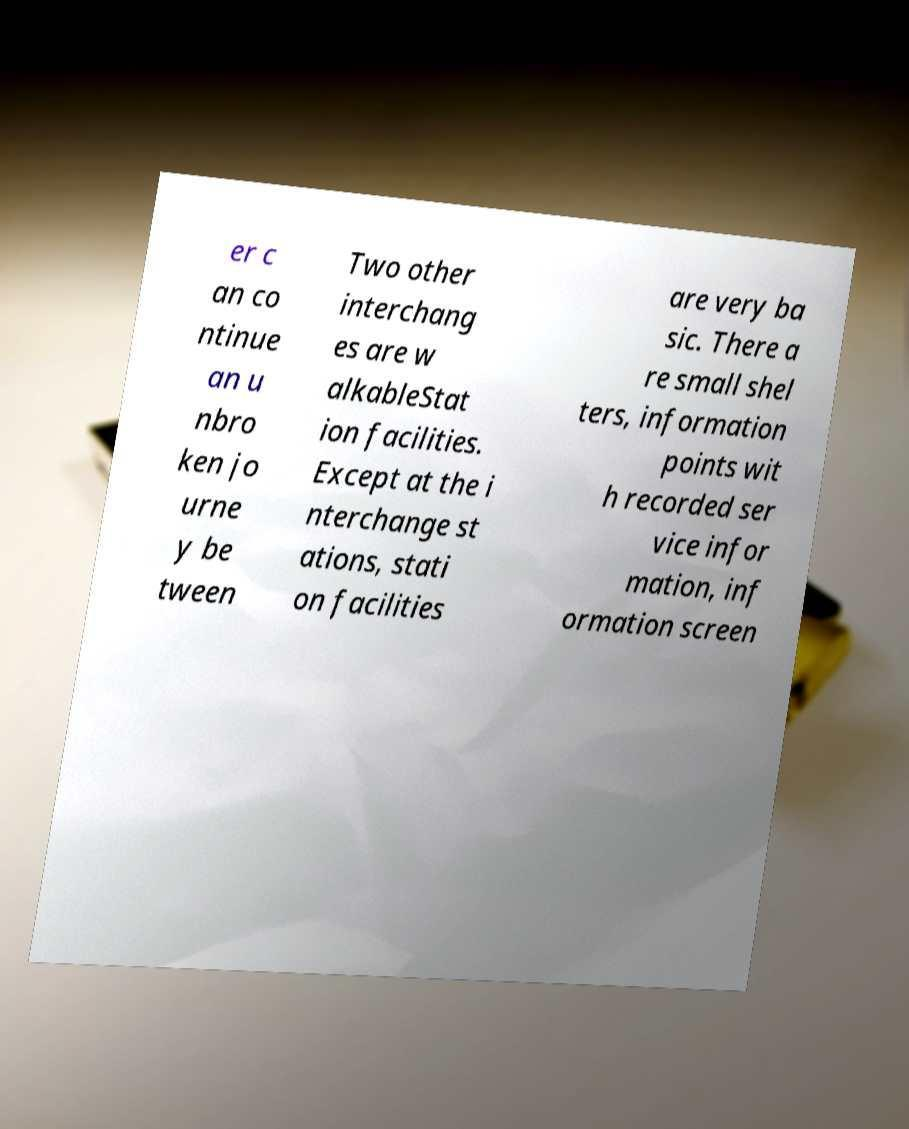Please identify and transcribe the text found in this image. er c an co ntinue an u nbro ken jo urne y be tween Two other interchang es are w alkableStat ion facilities. Except at the i nterchange st ations, stati on facilities are very ba sic. There a re small shel ters, information points wit h recorded ser vice infor mation, inf ormation screen 